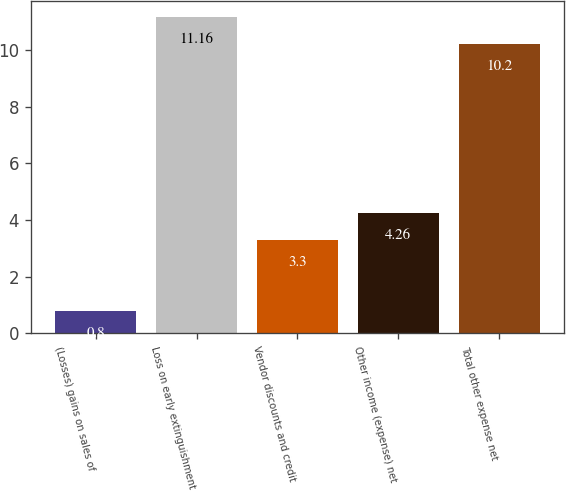Convert chart. <chart><loc_0><loc_0><loc_500><loc_500><bar_chart><fcel>(Losses) gains on sales of<fcel>Loss on early extinguishment<fcel>Vendor discounts and credit<fcel>Other income (expense) net<fcel>Total other expense net<nl><fcel>0.8<fcel>11.16<fcel>3.3<fcel>4.26<fcel>10.2<nl></chart> 